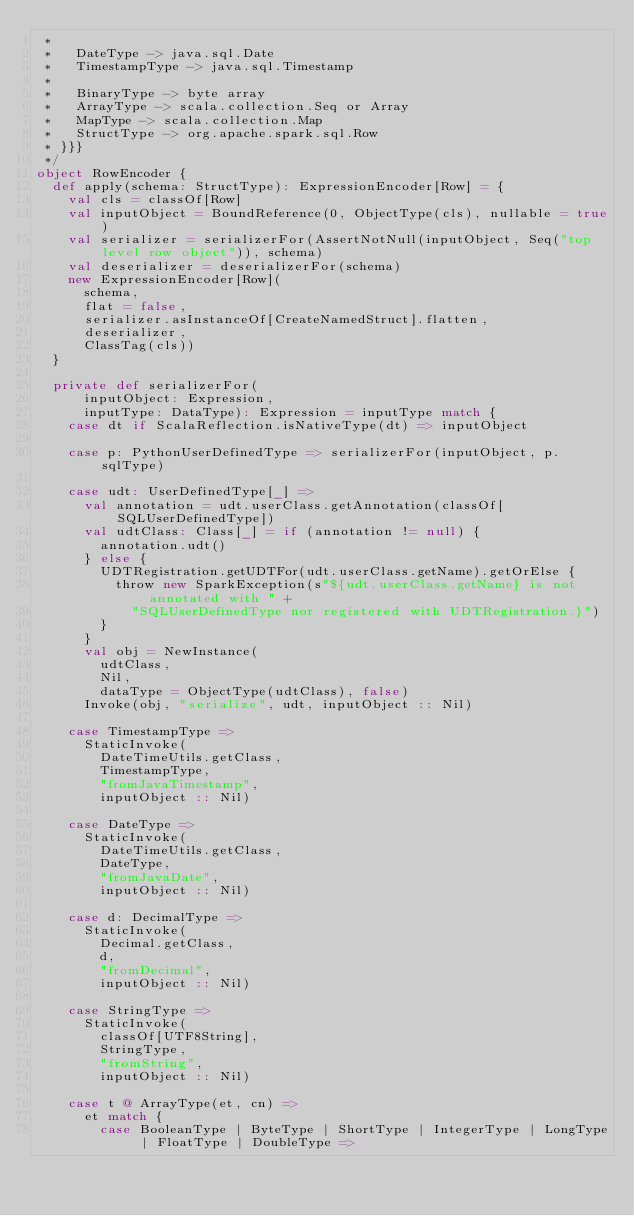Convert code to text. <code><loc_0><loc_0><loc_500><loc_500><_Scala_> *
 *   DateType -> java.sql.Date
 *   TimestampType -> java.sql.Timestamp
 *
 *   BinaryType -> byte array
 *   ArrayType -> scala.collection.Seq or Array
 *   MapType -> scala.collection.Map
 *   StructType -> org.apache.spark.sql.Row
 * }}}
 */
object RowEncoder {
  def apply(schema: StructType): ExpressionEncoder[Row] = {
    val cls = classOf[Row]
    val inputObject = BoundReference(0, ObjectType(cls), nullable = true)
    val serializer = serializerFor(AssertNotNull(inputObject, Seq("top level row object")), schema)
    val deserializer = deserializerFor(schema)
    new ExpressionEncoder[Row](
      schema,
      flat = false,
      serializer.asInstanceOf[CreateNamedStruct].flatten,
      deserializer,
      ClassTag(cls))
  }

  private def serializerFor(
      inputObject: Expression,
      inputType: DataType): Expression = inputType match {
    case dt if ScalaReflection.isNativeType(dt) => inputObject

    case p: PythonUserDefinedType => serializerFor(inputObject, p.sqlType)

    case udt: UserDefinedType[_] =>
      val annotation = udt.userClass.getAnnotation(classOf[SQLUserDefinedType])
      val udtClass: Class[_] = if (annotation != null) {
        annotation.udt()
      } else {
        UDTRegistration.getUDTFor(udt.userClass.getName).getOrElse {
          throw new SparkException(s"${udt.userClass.getName} is not annotated with " +
            "SQLUserDefinedType nor registered with UDTRegistration.}")
        }
      }
      val obj = NewInstance(
        udtClass,
        Nil,
        dataType = ObjectType(udtClass), false)
      Invoke(obj, "serialize", udt, inputObject :: Nil)

    case TimestampType =>
      StaticInvoke(
        DateTimeUtils.getClass,
        TimestampType,
        "fromJavaTimestamp",
        inputObject :: Nil)

    case DateType =>
      StaticInvoke(
        DateTimeUtils.getClass,
        DateType,
        "fromJavaDate",
        inputObject :: Nil)

    case d: DecimalType =>
      StaticInvoke(
        Decimal.getClass,
        d,
        "fromDecimal",
        inputObject :: Nil)

    case StringType =>
      StaticInvoke(
        classOf[UTF8String],
        StringType,
        "fromString",
        inputObject :: Nil)

    case t @ ArrayType(et, cn) =>
      et match {
        case BooleanType | ByteType | ShortType | IntegerType | LongType | FloatType | DoubleType =></code> 